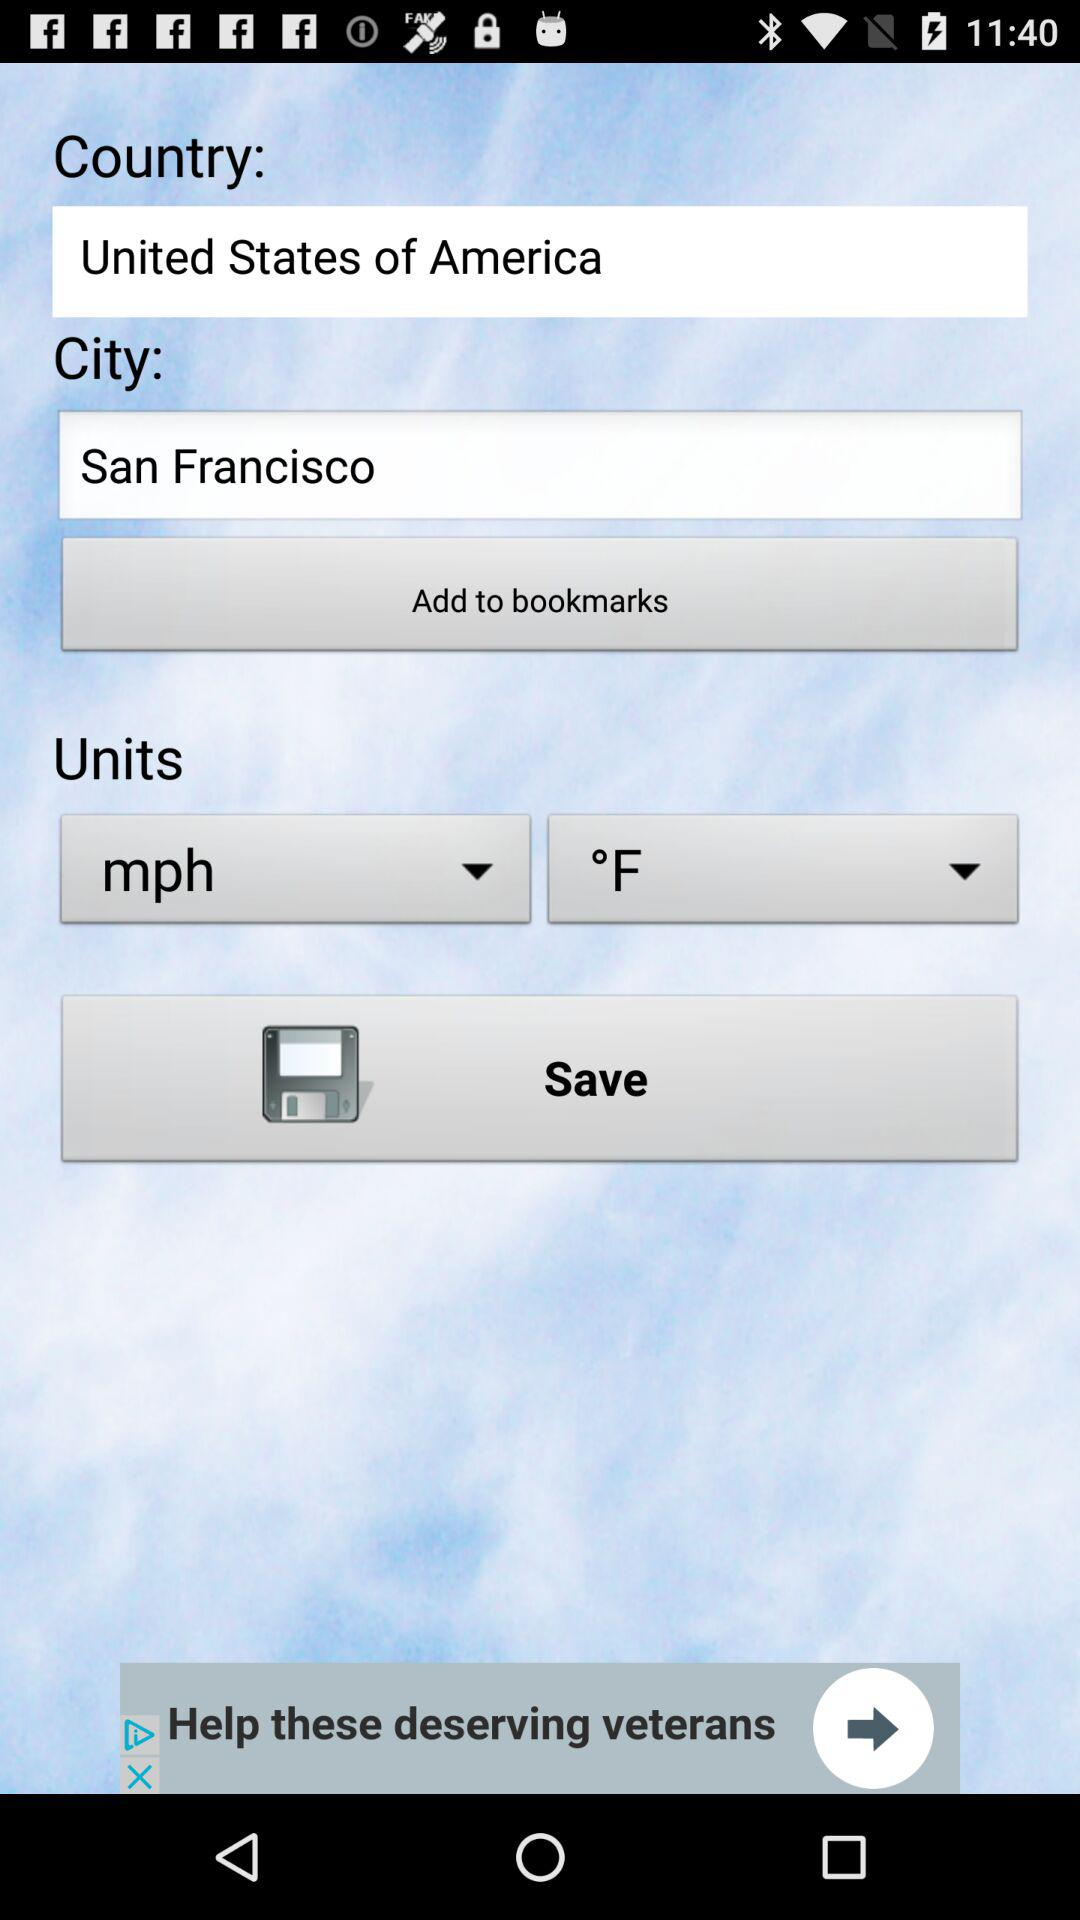What is the unit? The units are mph and °F. 